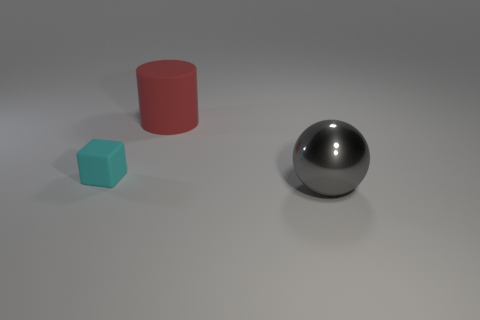Is the color of the small cube the same as the big object on the left side of the metal object?
Provide a succinct answer. No. There is a thing that is both left of the ball and on the right side of the cyan rubber thing; what is its shape?
Give a very brief answer. Cylinder. What number of big blue metallic objects are there?
Your response must be concise. 0. Do the large thing that is behind the large sphere and the small cyan thing have the same shape?
Offer a very short reply. No. What is the color of the matte object that is behind the small cyan block?
Your response must be concise. Red. How many other objects are the same size as the gray metallic sphere?
Your answer should be compact. 1. Is there any other thing that is the same shape as the small cyan thing?
Your answer should be very brief. No. Are there an equal number of rubber cylinders that are to the right of the red rubber thing and tiny blue cylinders?
Provide a succinct answer. Yes. What number of tiny cyan objects are made of the same material as the gray sphere?
Provide a short and direct response. 0. The other thing that is made of the same material as the small cyan object is what color?
Provide a short and direct response. Red. 